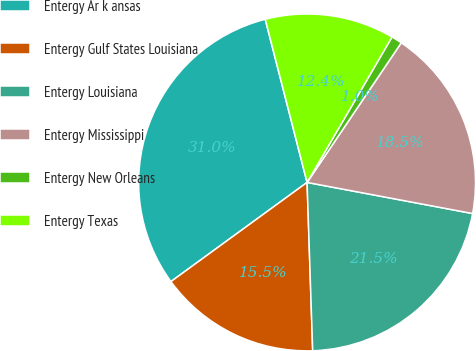Convert chart. <chart><loc_0><loc_0><loc_500><loc_500><pie_chart><fcel>Entergy Ar k ansas<fcel>Entergy Gulf States Louisiana<fcel>Entergy Louisiana<fcel>Entergy Mississippi<fcel>Entergy New Orleans<fcel>Entergy Texas<nl><fcel>31.02%<fcel>15.51%<fcel>21.51%<fcel>18.51%<fcel>1.03%<fcel>12.41%<nl></chart> 